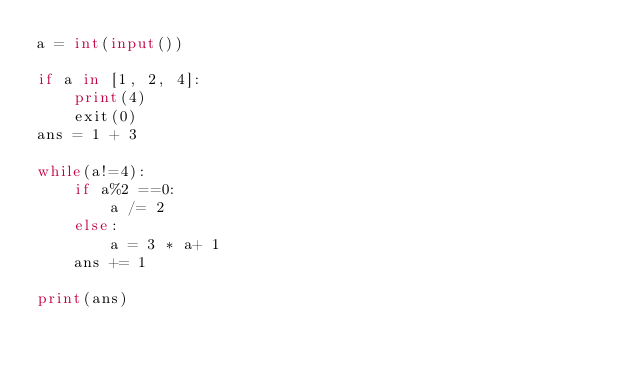<code> <loc_0><loc_0><loc_500><loc_500><_Python_>a = int(input())

if a in [1, 2, 4]:
    print(4)
    exit(0)
ans = 1 + 3

while(a!=4):
    if a%2 ==0:
        a /= 2
    else:
        a = 3 * a+ 1
    ans += 1

print(ans)
</code> 